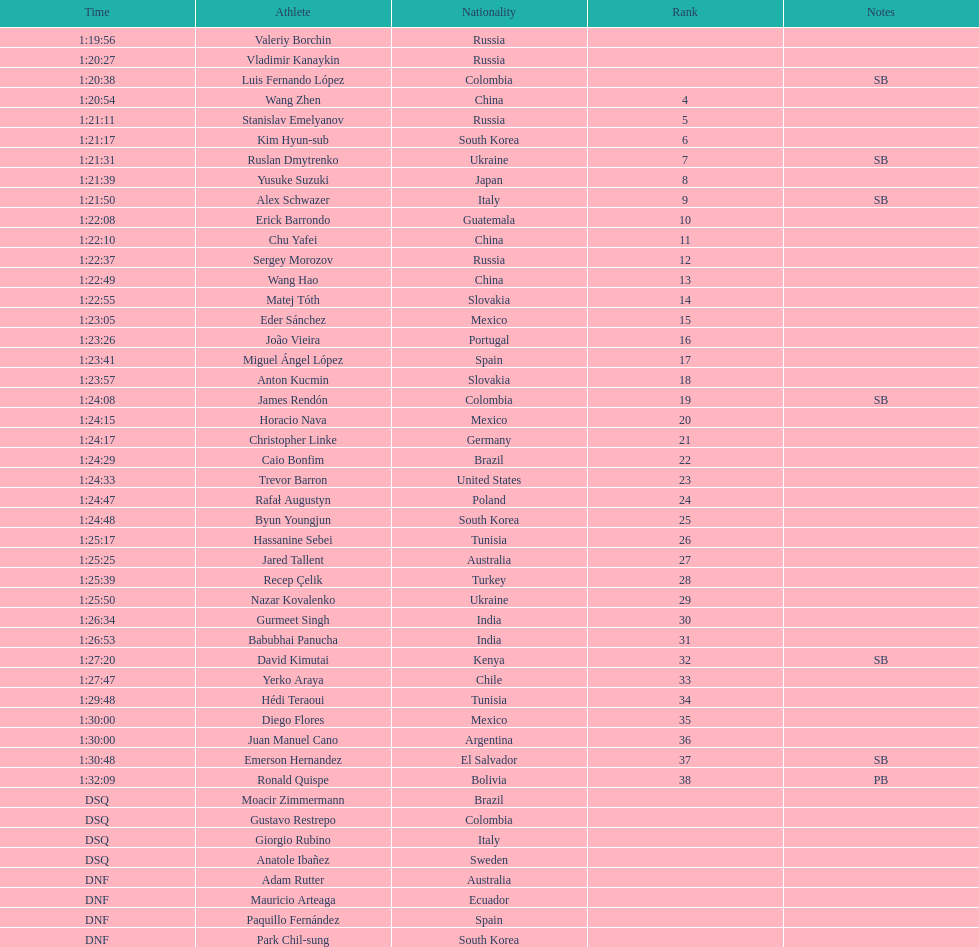Parse the table in full. {'header': ['Time', 'Athlete', 'Nationality', 'Rank', 'Notes'], 'rows': [['1:19:56', 'Valeriy Borchin', 'Russia', '', ''], ['1:20:27', 'Vladimir Kanaykin', 'Russia', '', ''], ['1:20:38', 'Luis Fernando López', 'Colombia', '', 'SB'], ['1:20:54', 'Wang Zhen', 'China', '4', ''], ['1:21:11', 'Stanislav Emelyanov', 'Russia', '5', ''], ['1:21:17', 'Kim Hyun-sub', 'South Korea', '6', ''], ['1:21:31', 'Ruslan Dmytrenko', 'Ukraine', '7', 'SB'], ['1:21:39', 'Yusuke Suzuki', 'Japan', '8', ''], ['1:21:50', 'Alex Schwazer', 'Italy', '9', 'SB'], ['1:22:08', 'Erick Barrondo', 'Guatemala', '10', ''], ['1:22:10', 'Chu Yafei', 'China', '11', ''], ['1:22:37', 'Sergey Morozov', 'Russia', '12', ''], ['1:22:49', 'Wang Hao', 'China', '13', ''], ['1:22:55', 'Matej Tóth', 'Slovakia', '14', ''], ['1:23:05', 'Eder Sánchez', 'Mexico', '15', ''], ['1:23:26', 'João Vieira', 'Portugal', '16', ''], ['1:23:41', 'Miguel Ángel López', 'Spain', '17', ''], ['1:23:57', 'Anton Kucmin', 'Slovakia', '18', ''], ['1:24:08', 'James Rendón', 'Colombia', '19', 'SB'], ['1:24:15', 'Horacio Nava', 'Mexico', '20', ''], ['1:24:17', 'Christopher Linke', 'Germany', '21', ''], ['1:24:29', 'Caio Bonfim', 'Brazil', '22', ''], ['1:24:33', 'Trevor Barron', 'United States', '23', ''], ['1:24:47', 'Rafał Augustyn', 'Poland', '24', ''], ['1:24:48', 'Byun Youngjun', 'South Korea', '25', ''], ['1:25:17', 'Hassanine Sebei', 'Tunisia', '26', ''], ['1:25:25', 'Jared Tallent', 'Australia', '27', ''], ['1:25:39', 'Recep Çelik', 'Turkey', '28', ''], ['1:25:50', 'Nazar Kovalenko', 'Ukraine', '29', ''], ['1:26:34', 'Gurmeet Singh', 'India', '30', ''], ['1:26:53', 'Babubhai Panucha', 'India', '31', ''], ['1:27:20', 'David Kimutai', 'Kenya', '32', 'SB'], ['1:27:47', 'Yerko Araya', 'Chile', '33', ''], ['1:29:48', 'Hédi Teraoui', 'Tunisia', '34', ''], ['1:30:00', 'Diego Flores', 'Mexico', '35', ''], ['1:30:00', 'Juan Manuel Cano', 'Argentina', '36', ''], ['1:30:48', 'Emerson Hernandez', 'El Salvador', '37', 'SB'], ['1:32:09', 'Ronald Quispe', 'Bolivia', '38', 'PB'], ['DSQ', 'Moacir Zimmermann', 'Brazil', '', ''], ['DSQ', 'Gustavo Restrepo', 'Colombia', '', ''], ['DSQ', 'Giorgio Rubino', 'Italy', '', ''], ['DSQ', 'Anatole Ibañez', 'Sweden', '', ''], ['DNF', 'Adam Rutter', 'Australia', '', ''], ['DNF', 'Mauricio Arteaga', 'Ecuador', '', ''], ['DNF', 'Paquillo Fernández', 'Spain', '', ''], ['DNF', 'Park Chil-sung', 'South Korea', '', '']]} Which athlete had the fastest time for the 20km? Valeriy Borchin. 